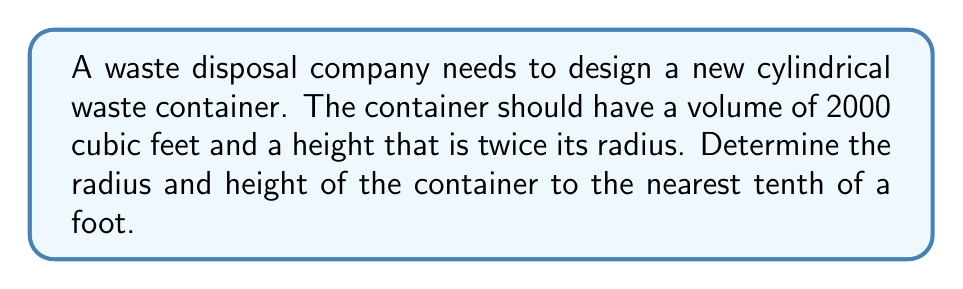What is the answer to this math problem? Let's approach this step-by-step:

1) Let $r$ be the radius of the cylinder and $h$ be its height.

2) We're given that the height is twice the radius, so:
   $h = 2r$

3) The volume of a cylinder is given by the formula:
   $V = \pi r^2 h$

4) We know the volume is 2000 cubic feet, so:
   $2000 = \pi r^2 h$

5) Substituting $h = 2r$ into this equation:
   $2000 = \pi r^2 (2r)$
   $2000 = 2\pi r^3$

6) Solving for $r$:
   $r^3 = \frac{2000}{2\pi}$
   $r^3 = \frac{1000}{\pi}$
   $r = \sqrt[3]{\frac{1000}{\pi}}$

7) Using a calculator and rounding to the nearest tenth:
   $r \approx 6.2$ feet

8) Since $h = 2r$, the height is:
   $h \approx 2(6.2) = 12.4$ feet

9) Let's verify the volume:
   $V = \pi r^2 h = \pi (6.2)^2 (12.4) \approx 1999.9$ cubic feet
   This is very close to 2000 cubic feet, confirming our calculation.
Answer: The cylindrical waste container should have a radius of approximately 6.2 feet and a height of approximately 12.4 feet. 